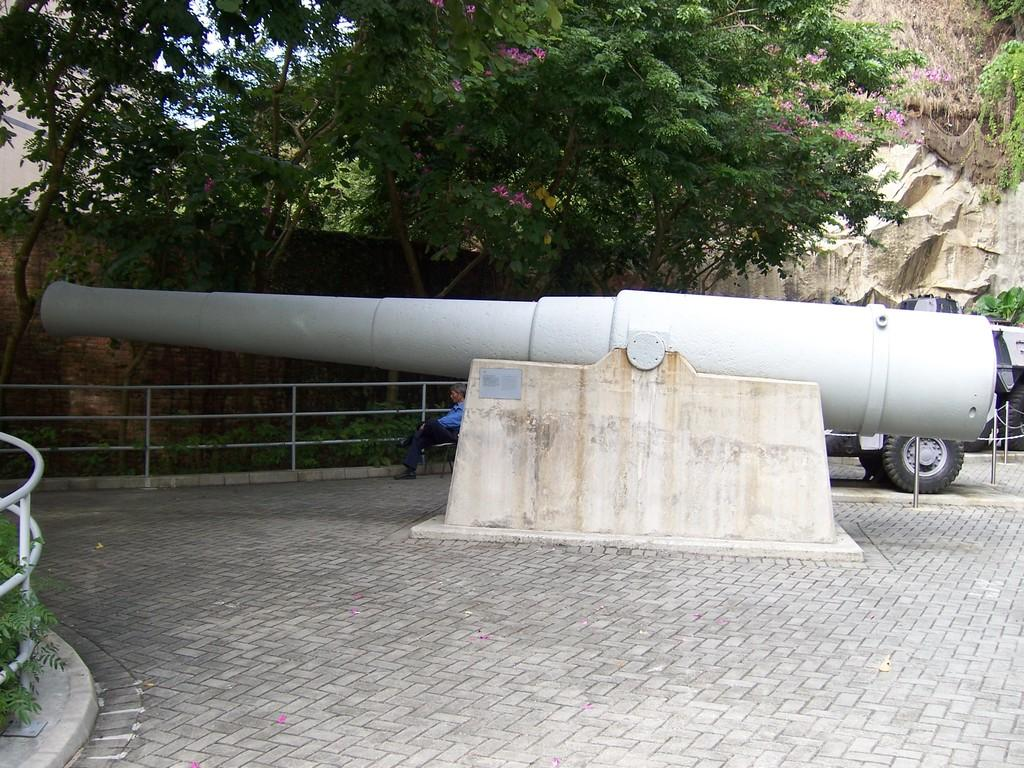What type of natural elements can be seen in the image? There are trees in the image. What man-made structure is present in the image? There is a fence in the image. What mode of transportation can be seen in the image? There is a vehicle in the image. What historical or military object is present in the image? There is a canon in the image. What objects are on the ground in the image? There are objects on the ground in the image. What is visible in the background of the image? The sky is visible in the background of the image. What is the person in the image doing? There is a person sitting on a chair in the image. What type of tomatoes are being harvested on the stage in the image? There is no stage or tomatoes present in the image. What type of weather condition is visible in the image? The provided facts do not mention any specific weather conditions, so we cannot determine if sleet is visible in the image. 